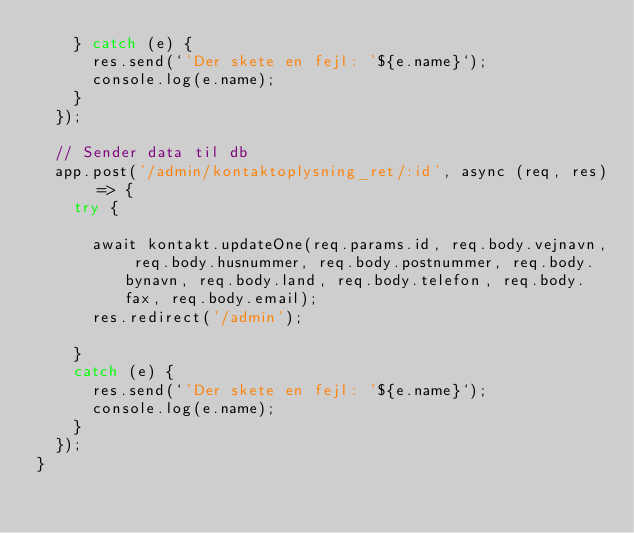Convert code to text. <code><loc_0><loc_0><loc_500><loc_500><_JavaScript_>    } catch (e) {
      res.send(`'Der skete en fejl: '${e.name}`);
      console.log(e.name);
    }
  });

  // Sender data til db
  app.post('/admin/kontaktoplysning_ret/:id', async (req, res) => {
    try {
      
      await kontakt.updateOne(req.params.id, req.body.vejnavn, req.body.husnummer, req.body.postnummer, req.body.bynavn, req.body.land, req.body.telefon, req.body.fax, req.body.email);
      res.redirect('/admin');

    }
    catch (e) {
      res.send(`'Der skete en fejl: '${e.name}`);
      console.log(e.name);
    }
  });
} </code> 